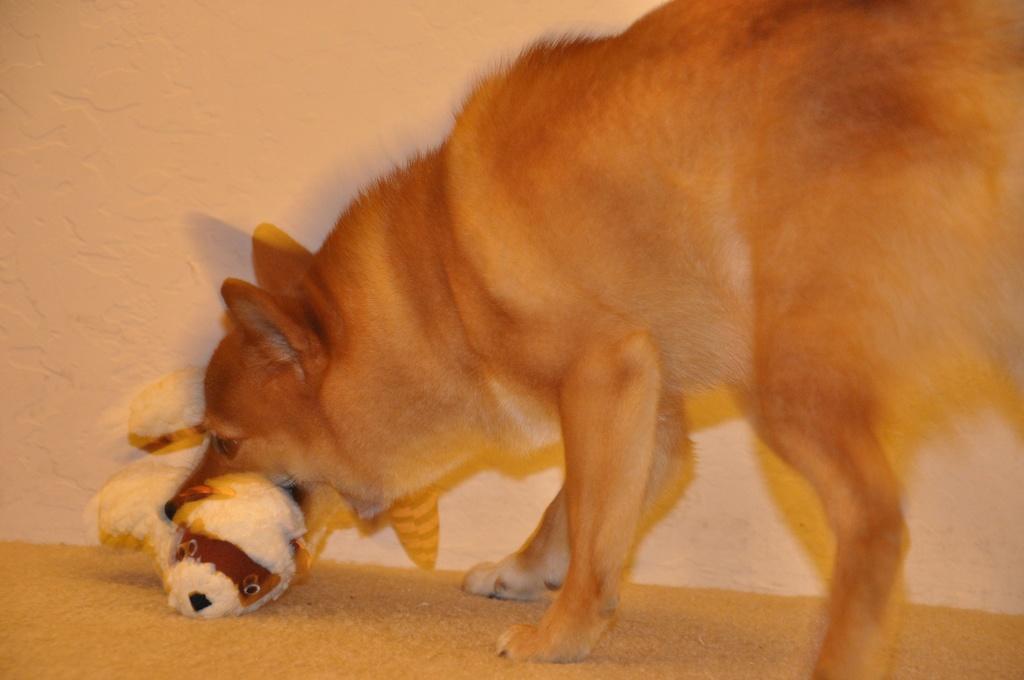How would you summarize this image in a sentence or two? Here in this picture we can see a dog holding a toy in its mouth, which is present on the floor over there. 